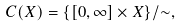<formula> <loc_0><loc_0><loc_500><loc_500>C ( X ) = \{ [ 0 , \infty ] \times X \} / \sim ,</formula> 